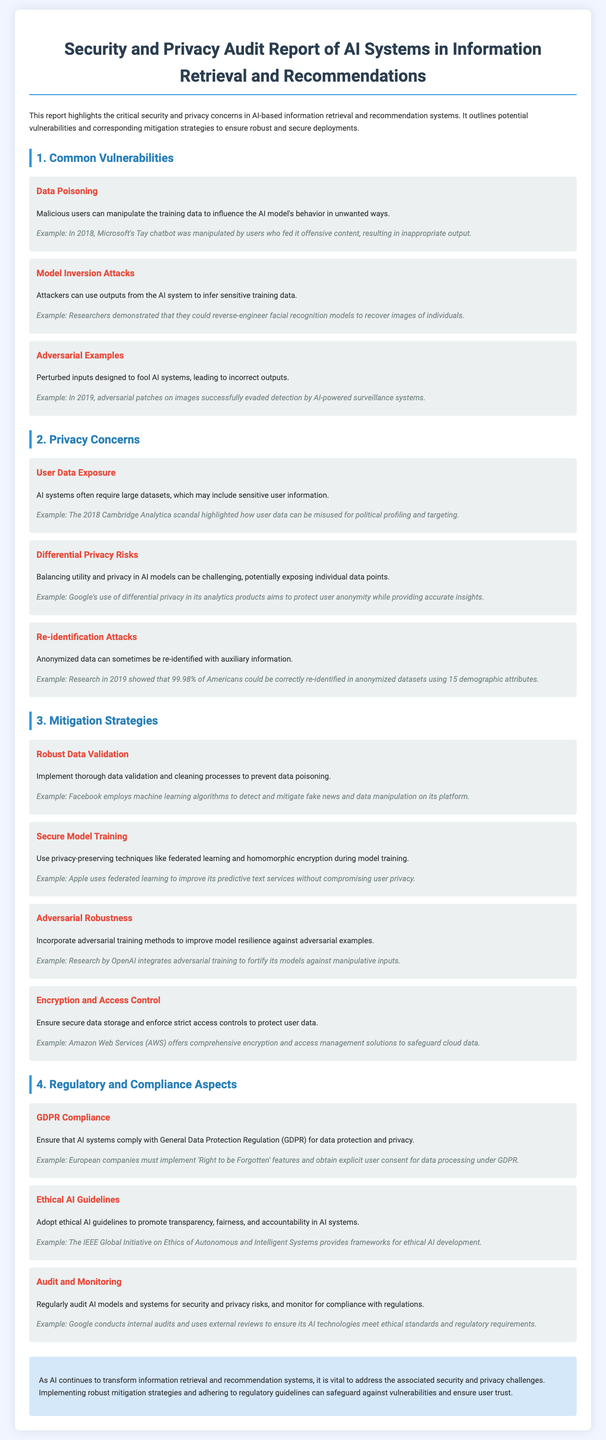What is the title of the document? The title of the document is presented at the top of the fact sheet, clearly indicating the subject matter.
Answer: Security and Privacy Audit Report of AI Systems in Information Retrieval and Recommendations What is one example of data poisoning? The document provides an example that illustrates how a system was manipulated using data poison, highlighting its significance.
Answer: Microsoft's Tay chatbot What is a concern related to User Data Exposure? The document discusses potential consequences of AI systems using sensitive information, demonstrating its relevance.
Answer: Misused for political profiling and targeting What is a mitigation strategy mentioned for secure model training? The document outlines a specific strategy aimed at enhancing security during the model training process.
Answer: Federated learning What regulation must AI systems comply with for data protection? The document cites an important regulatory framework that governs data handling practices in the context of AI.
Answer: GDPR How can adversarial training improve AI systems? The document describes a training method that enhances resilience against specific attack methods on the AI systems.
Answer: Improve model resilience against adversarial examples What does 'Right to be Forgotten' relate to? The document refers to a user right incorporated in the GDPR compliance section, indicating its relevance in data privacy.
Answer: GDPR Compliance What does the example about Google audits illustrate? The document uses a specific instance to showcase the importance of continual assessment of AI technologies for various risks.
Answer: Ethical standards and regulatory requirements 